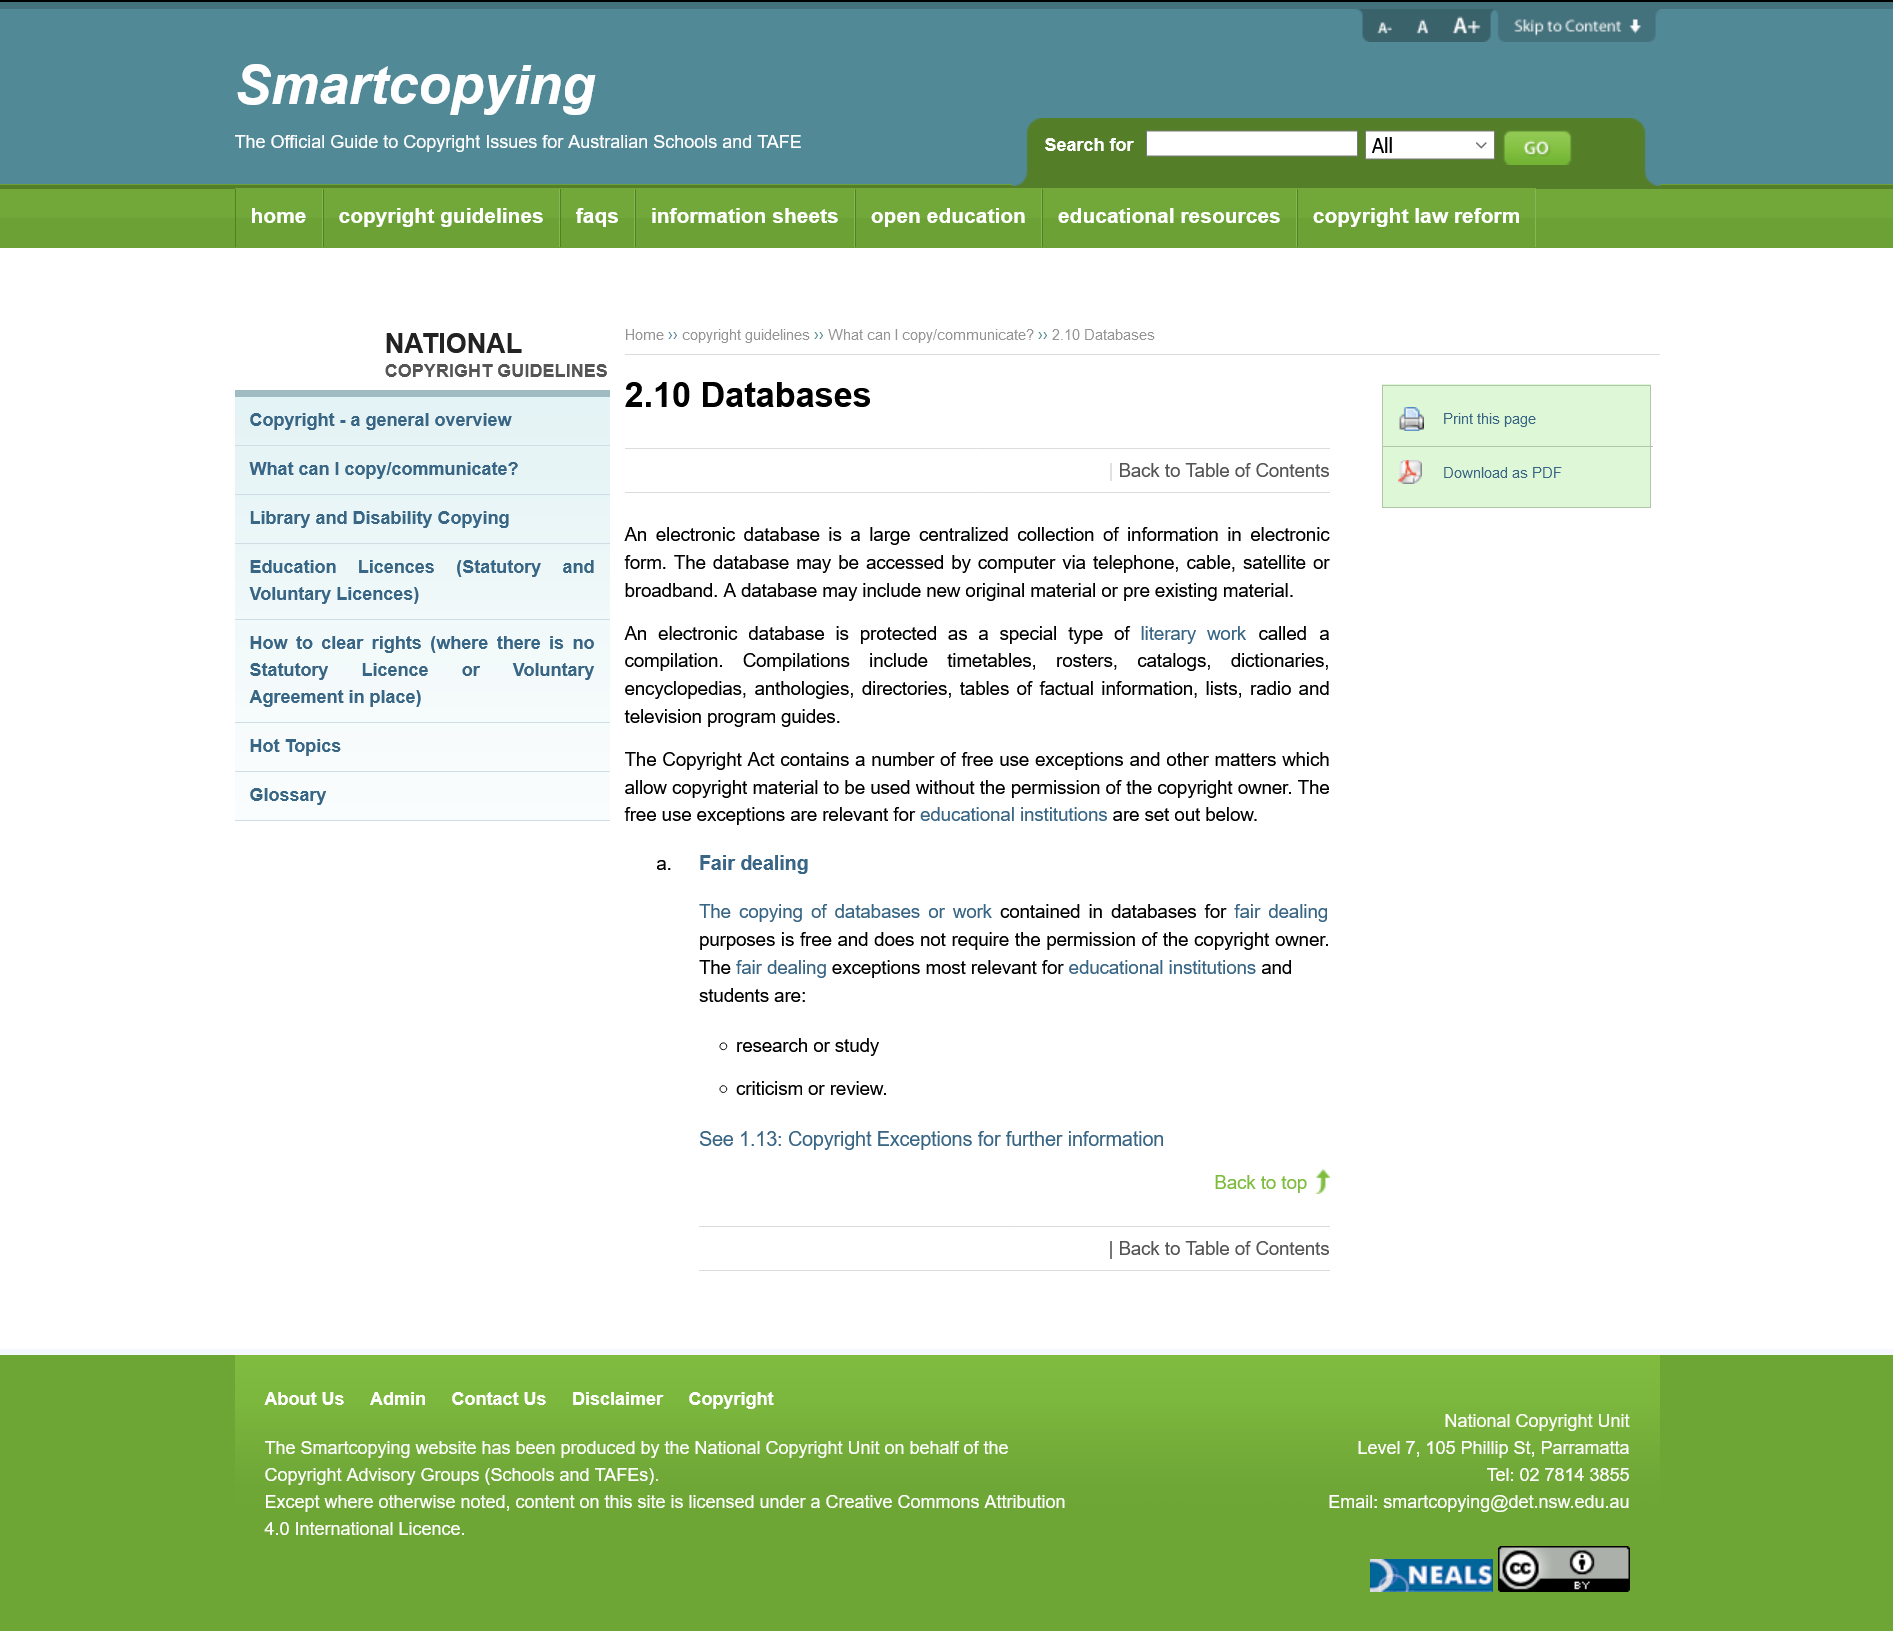Highlight a few significant elements in this photo. Research, study, and criticism or review are the fair dealing exceptions that are most relevant for educational institutions and students. An electronic database is protected as a special type of literary work known as a compilation, which includes source code, object code, and data structures. An electronic database is a large, centralized collection of information in electronic form that is stored and maintained on a computer system or network. 